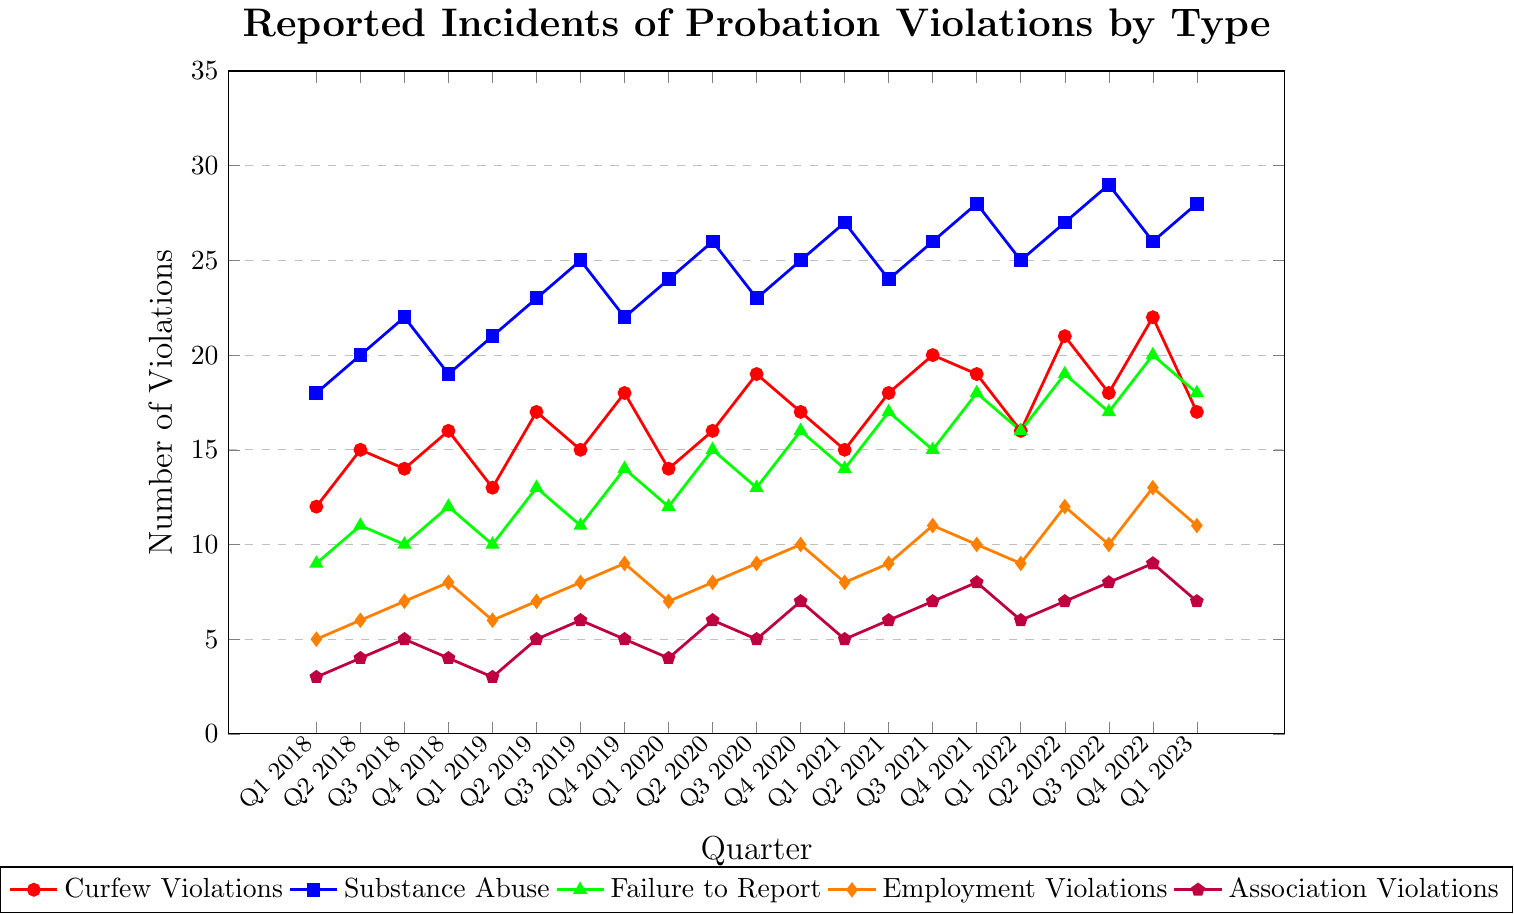What's the highest number of Substance Abuse violations reported in a quarter? To find the highest number of reported Substance Abuse violations over the quarters, inspect the blue line representing Substance Abuse violations and identify the peak value. The highest point is Q3 2022 with 29 violations.
Answer: 29 Which type of violation had the highest increase from Q1 2018 to Q1 2023? Compare the number of violations at Q1 2018 and Q1 2023 for each violation type. Calculate the differences: Curfew Violations increased from 12 to 17 (+5), Substance Abuse from 18 to 28 (+10), Failure to Report from 9 to 18 (+9), Employment Violations from 5 to 11 (+6), and Association Violations from 3 to 7 (+4). Substance Abuse saw the highest increase of +10.
Answer: Substance Abuse What is the average number of Employment Violations reported annually from 2018 to 2022? Identify the number of Employment Violations for each year and calculate their averages: 2018: (5+6+7+8)/4=6.5, 2019: (6+7+8+9)/4=7.5, 2020: (7+8+9+10)/4=8.5, 2021: (8+9+11+10)/4=9.5, 2022: (9+12+10+13)/4=11.  Average is (6.5+7.5+8.5+9.5+11)/5=8.6.
Answer: 8.6 In which quarter and year did Association Violations reach their peak? Examine the purple line representing Association Violations and locate the quarter with the highest number of violations. The peak of 9 violations occurs in Q4 2022.
Answer: Q4 2022 Which year had the highest total number of Substance Abuse violations? Sum the number of Substance Abuse violations for each year and compare: 2018: 79, 2019: 91, 2020: 96, 2021: 105, 2022: 107. The highest total is in 2022.
Answer: 2022 What is the combined total of Curfew Violations and Failure to Report violations for Q4 2021? Add the number of Curfew Violations (19) and Failure to Report violations (18) for Q4 2021. Combined total is 19 + 18 = 37.
Answer: 37 By how much did the number of Curfew Violations change from Q2 2022 to Q4 2022? Find the difference in the number of Curfew Violations between Q2 2022 (21) and Q4 2022 (22). The change is 22 - 21 = 1.
Answer: 1 Which type of violation consistently showed an upward trend over the 5 years? Observe all lines to identify any that demonstrate a consistent increase over the quarters. The Substance Abuse violations line (blue) shows an overall increasing trend.
Answer: Substance Abuse 